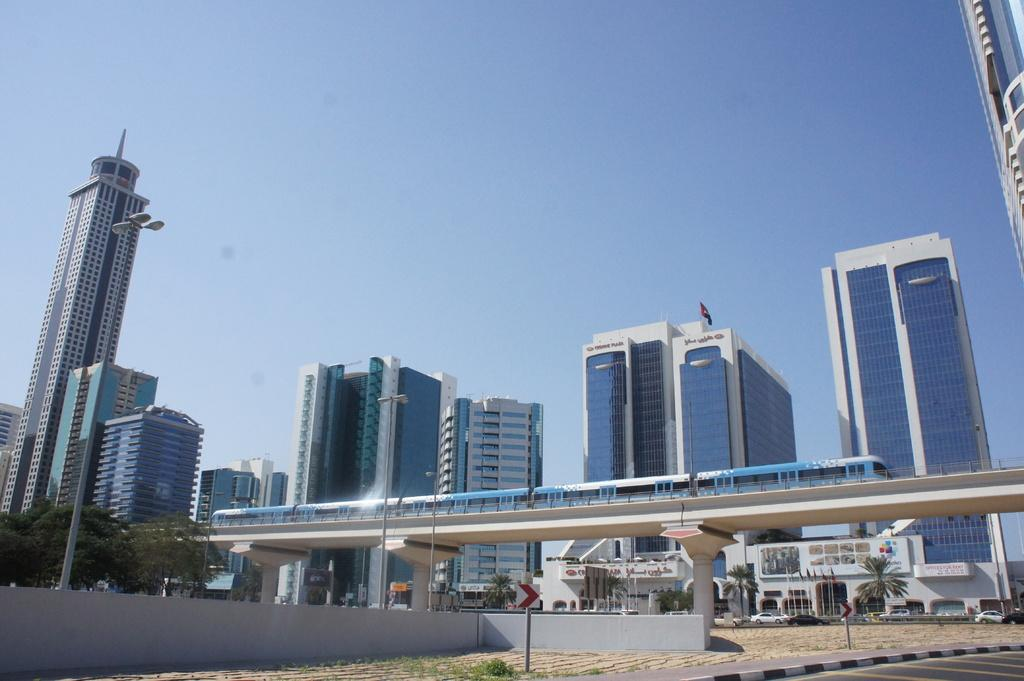What is the main subject of the image? The main subject of the image is a train on a bridge. What can be seen in the background of the image? There are trees, walls, light poles, flags, buildings, vehicles, and boards visible in the image. What is the color of the sky in the image? The sky is blue in the image. What type of game is being played on the train in the image? There is no indication of a game being played on the train in the image. What is the train using to carry the sack in the image? There is no sack present in the image, and the train is not carrying anything. 